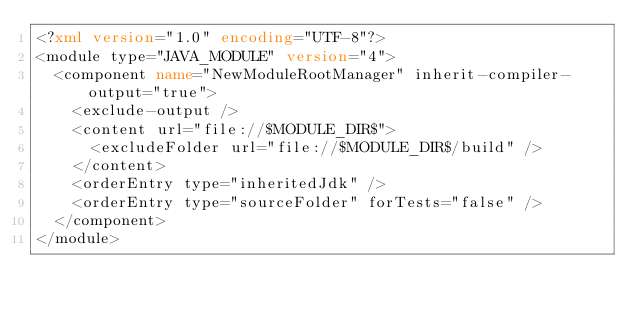Convert code to text. <code><loc_0><loc_0><loc_500><loc_500><_XML_><?xml version="1.0" encoding="UTF-8"?>
<module type="JAVA_MODULE" version="4">
  <component name="NewModuleRootManager" inherit-compiler-output="true">
    <exclude-output />
    <content url="file://$MODULE_DIR$">
      <excludeFolder url="file://$MODULE_DIR$/build" />
    </content>
    <orderEntry type="inheritedJdk" />
    <orderEntry type="sourceFolder" forTests="false" />
  </component>
</module></code> 